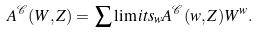Convert formula to latex. <formula><loc_0><loc_0><loc_500><loc_500>A ^ { \mathcal { C } } ( W , Z ) = \, \sum \lim i t s _ { w } A ^ { \mathcal { C } } ( w , Z ) W ^ { w } .</formula> 